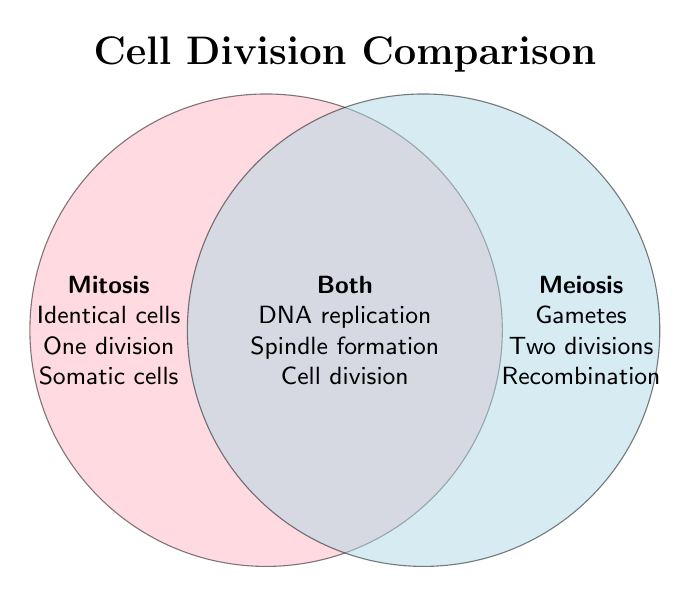What is the title of the Venn Diagram? The title is found at the top center of the Venn Diagram and is displayed in a larger and bold font compared to other text.
Answer: Cell Division Comparison What kind of cells does meiosis produce? This information is located inside the right circle labeled "Meiosis."
Answer: Gametes Which process involves only one division? The left circle labeled "Mitosis" contains this information.
Answer: Mitosis What is a common feature of both mitosis and meiosis related to the genetic material? The overlapping section labeled "Both" lists shared features.
Answer: DNA replication How does mitosis differ from meiosis in terms of chromosomal changes? Look for unique descriptions in each of the individual circles labeled "Mitosis" and "Meiosis."
Answer: Mitosis maintains the chromosome number; meiosis reduces it What happens during meiosis but not during mitosis in terms of chromosomes? This specific feature is listed under the "Meiosis" circle.
Answer: Genetic recombination Which cell division process occurs in somatic cells? Check the left "Mitosis" circle for details on where the process occurs.
Answer: Mitosis Which shared process between mitosis and meiosis involves the same cellular event? Refer to features listed in the overlapping section "Both" that describe common cell activities.
Answer: Cell division How many divisions occur in meiosis compared to mitosis? Compare the unique features listed under the "Meiosis" and "Mitosis" circles.
Answer: Meiosis has two divisions while mitosis has one Which process does not include any crossing over of genetic material? Look for this unique feature in the left "Mitosis" circle.
Answer: Mitosis 